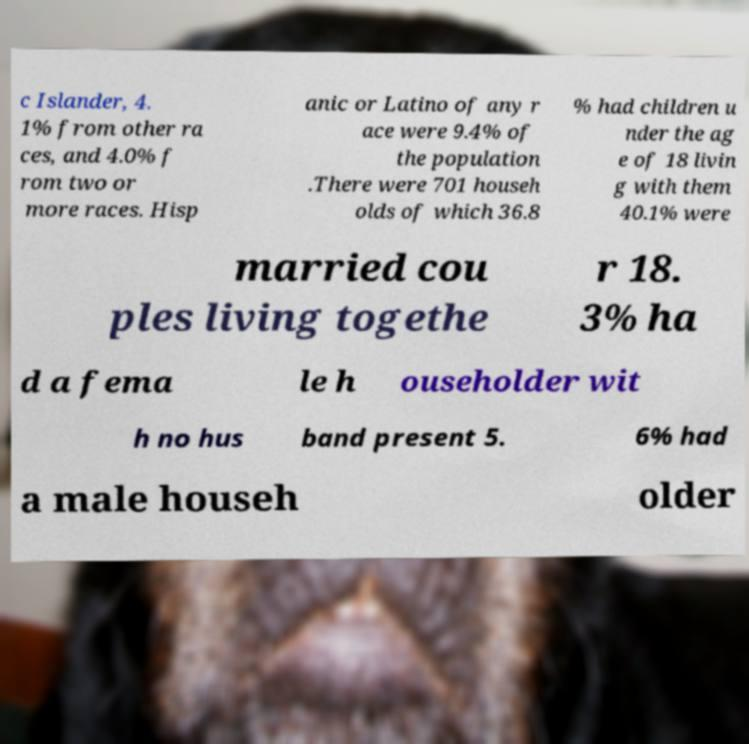Please identify and transcribe the text found in this image. c Islander, 4. 1% from other ra ces, and 4.0% f rom two or more races. Hisp anic or Latino of any r ace were 9.4% of the population .There were 701 househ olds of which 36.8 % had children u nder the ag e of 18 livin g with them 40.1% were married cou ples living togethe r 18. 3% ha d a fema le h ouseholder wit h no hus band present 5. 6% had a male househ older 